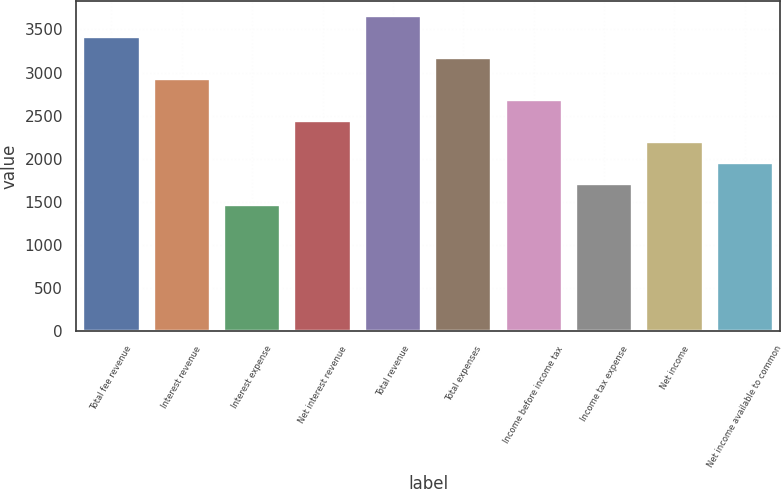Convert chart. <chart><loc_0><loc_0><loc_500><loc_500><bar_chart><fcel>Total fee revenue<fcel>Interest revenue<fcel>Interest expense<fcel>Net interest revenue<fcel>Total revenue<fcel>Total expenses<fcel>Income before income tax<fcel>Income tax expense<fcel>Net income<fcel>Net income available to common<nl><fcel>3408.84<fcel>2921.9<fcel>1461.08<fcel>2434.96<fcel>3652.31<fcel>3165.37<fcel>2678.43<fcel>1704.55<fcel>2191.49<fcel>1948.02<nl></chart> 